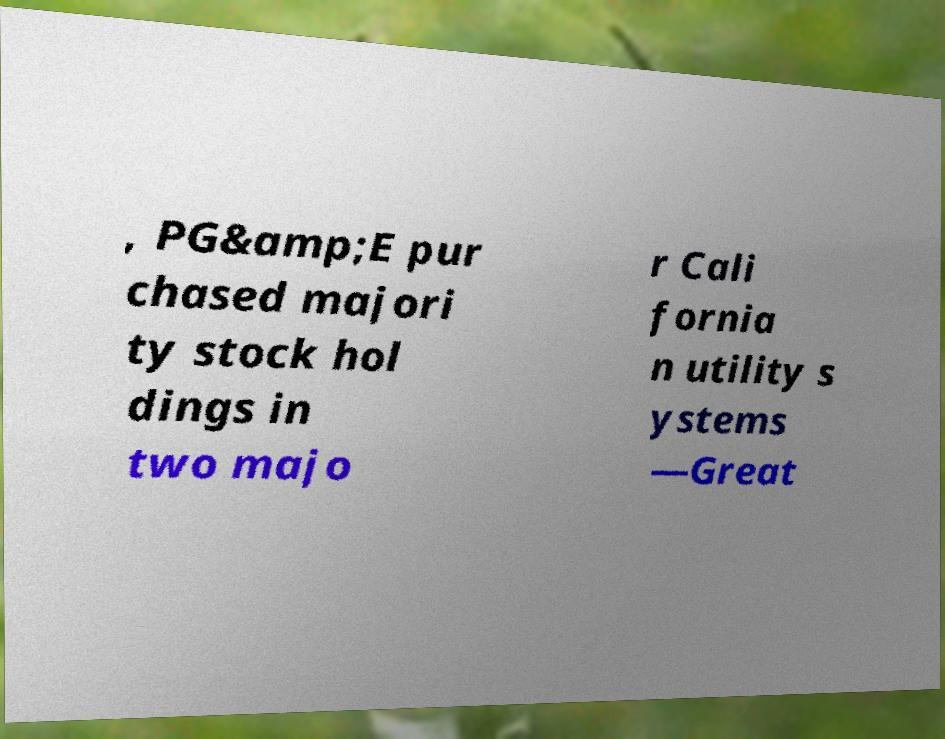There's text embedded in this image that I need extracted. Can you transcribe it verbatim? , PG&amp;E pur chased majori ty stock hol dings in two majo r Cali fornia n utility s ystems —Great 